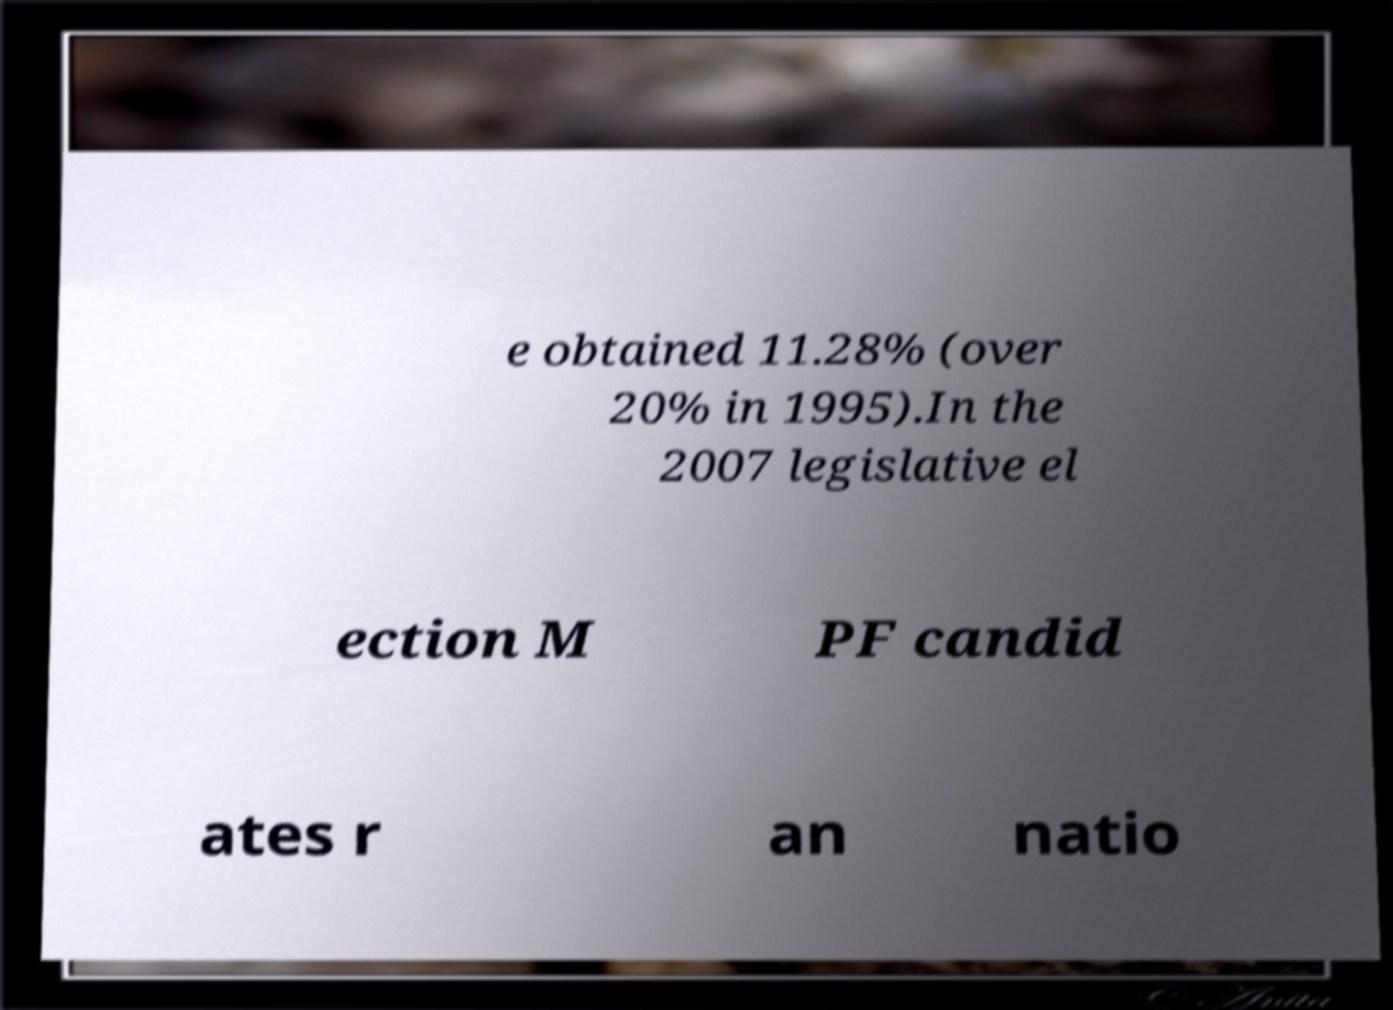I need the written content from this picture converted into text. Can you do that? e obtained 11.28% (over 20% in 1995).In the 2007 legislative el ection M PF candid ates r an natio 